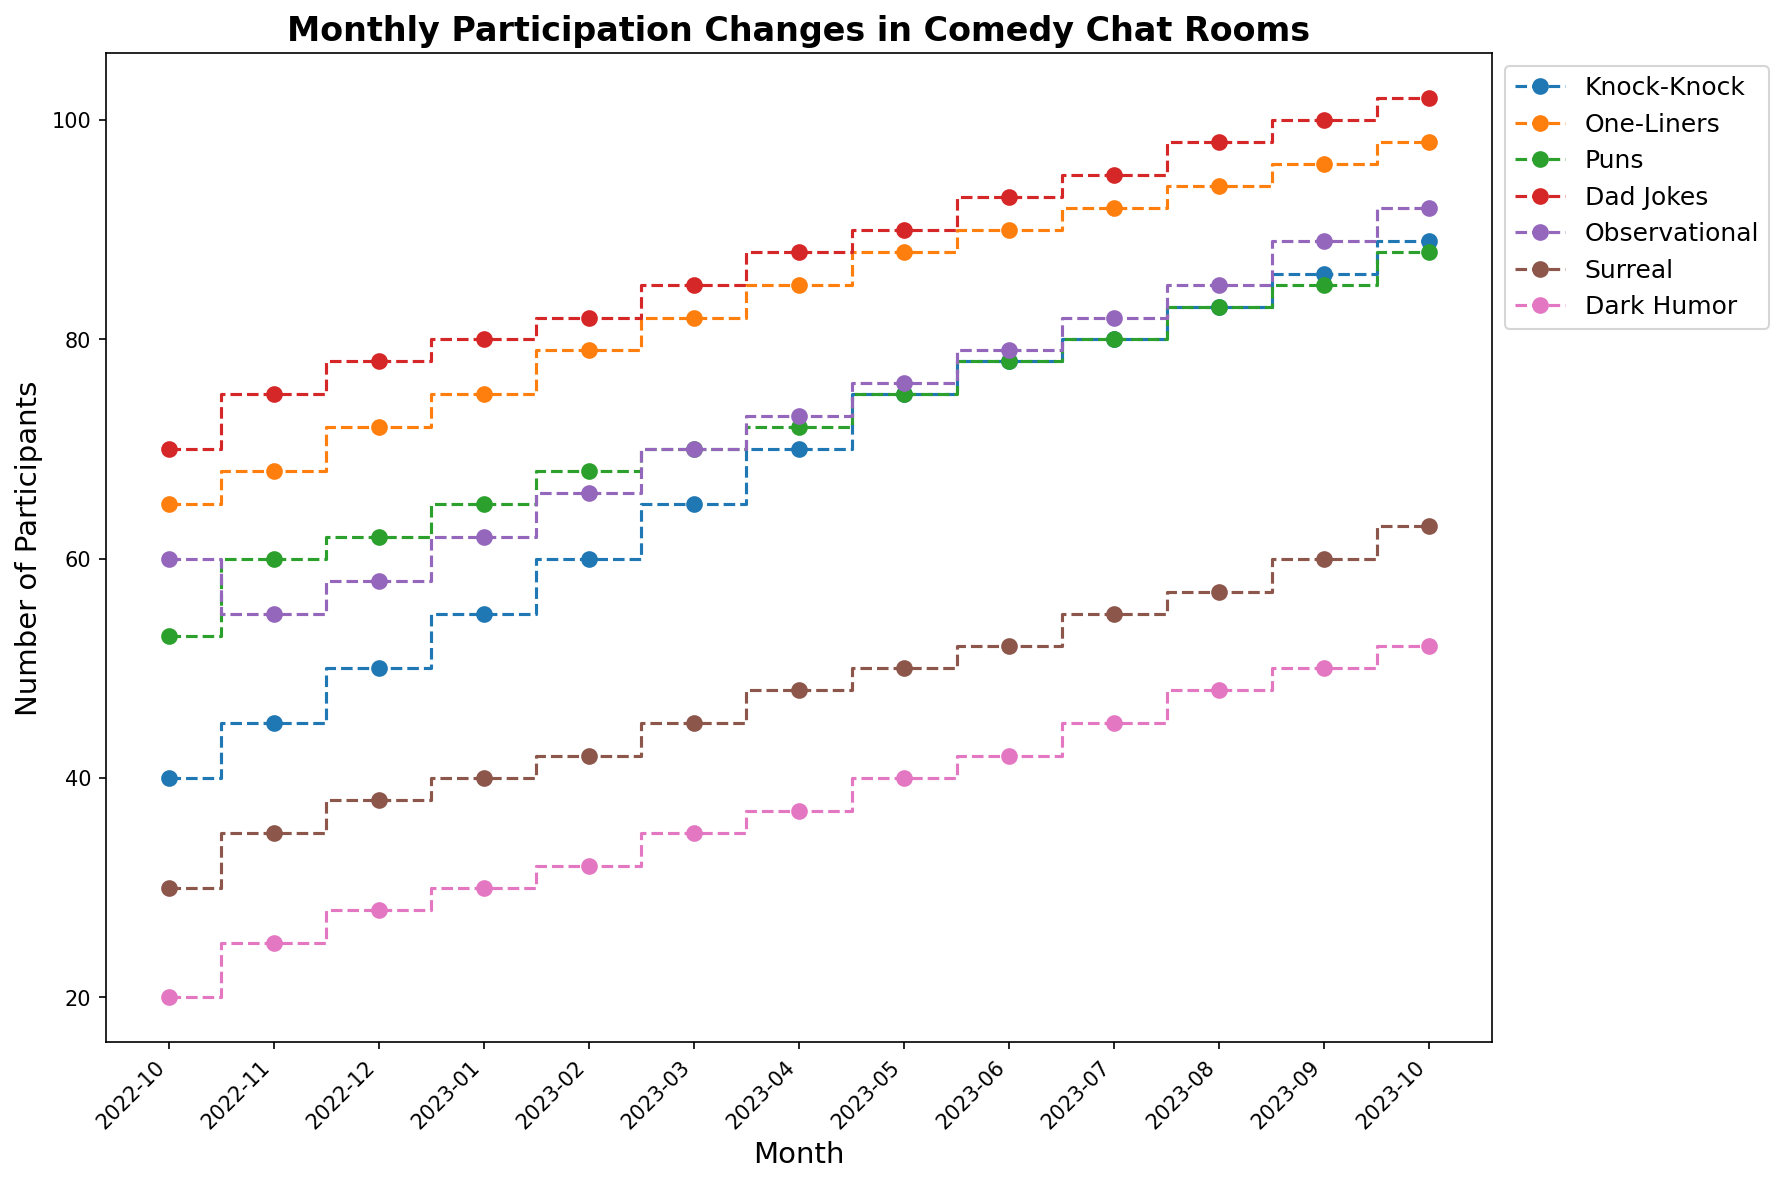What is the trend of participation in Dad Jokes over the last year? The trend is determined by examining the data points for Dad Jokes over each month. Participation goes from 70 in October 2022 to 102 in October 2023, consistently increasing each month.
Answer: Increasing Which joke type had the highest number of participants in October 2023? By examining the y-axis values for each joke type in October 2023, we see Dad Jokes peaked at 102, the highest among all categories.
Answer: Dad Jokes What is the difference in participation between Knock-Knock jokes and One-Liners in March 2023? In March 2023, Knock-Knock jokes had 65 participants and One-Liners had 82 participants. The difference is calculated as 82 - 65.
Answer: 17 When did Puns see an increase to 75 participants? We track the participation values for Puns and see they reach 75 in May 2023.
Answer: May 2023 By how much did participation in Dark Humor increase from October 2022 to October 2023? Dark Humor participation increased from 20 in October 2022 to 52 in October 2023. The increase is 52 - 20.
Answer: 32 Which joke type saw the largest growth in participant numbers from October 2022 to October 2023? By calculating the difference in participant numbers for each joke type between these months, Dad Jokes had the largest growth with an increase from 70 to 102, which is 32.
Answer: Dad Jokes Did Observational humor have more participants than One-Liners in June 2023? Observational humor had 79 participants and One-Liners had 90 participants in June 2023. Observational humor had fewer participants.
Answer: No Which two joke types had almost the same number of participants in July 2023? Observational humor and Dad Jokes had 82 and 95 participants, respectively.
Answer: One-Liners and Puns both had 80 participants What's the average participation for Surreal humor across the year? Adding all participation values for Surreal humor and dividing by the number of months: (30 + 35 + 38 + 40 + 42 + 45 + 48 + 50 + 52 + 55 + 57 + 60 + 63) / 13. The total is 615, giving us an average of 47.31.
Answer: 47.31 